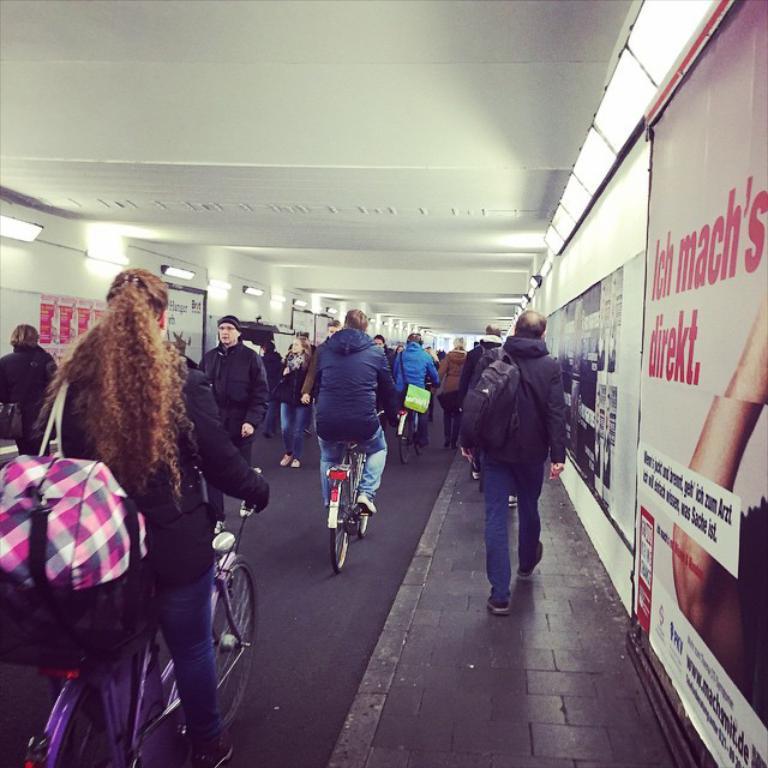Can you describe this image briefly? As we can see in the image there are banners, few people here are their and there are bicycles. 